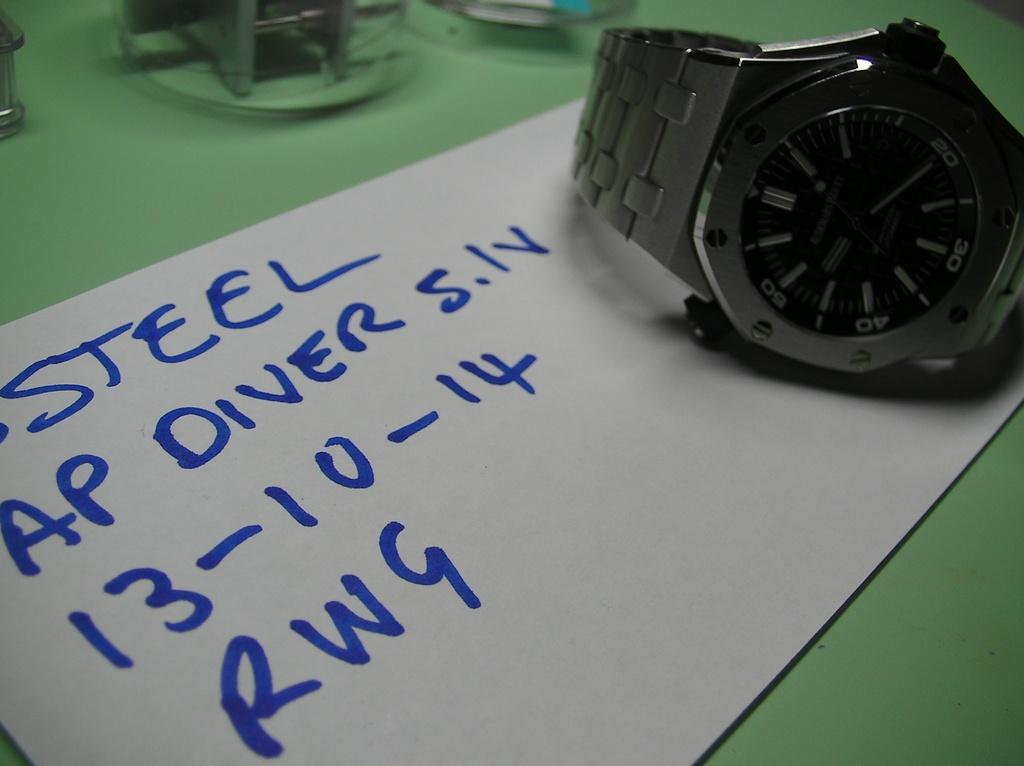<image>
Share a concise interpretation of the image provided. A watch on a piece of paper which reads Steel at the top 